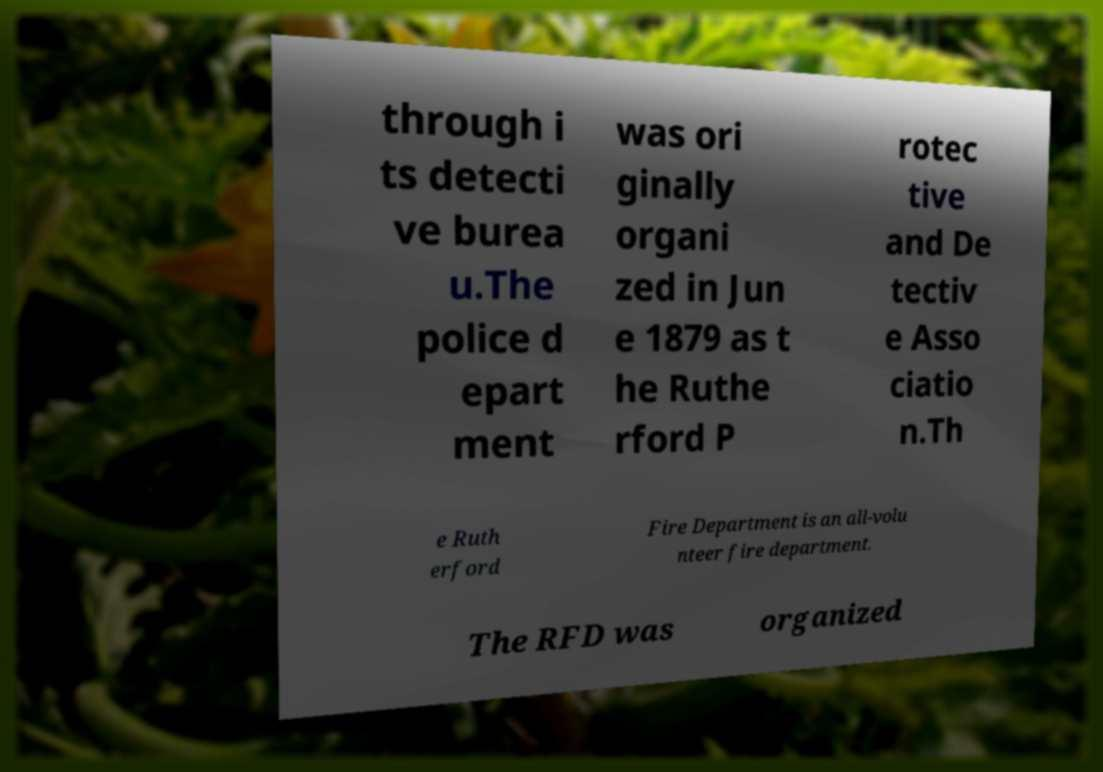For documentation purposes, I need the text within this image transcribed. Could you provide that? through i ts detecti ve burea u.The police d epart ment was ori ginally organi zed in Jun e 1879 as t he Ruthe rford P rotec tive and De tectiv e Asso ciatio n.Th e Ruth erford Fire Department is an all-volu nteer fire department. The RFD was organized 